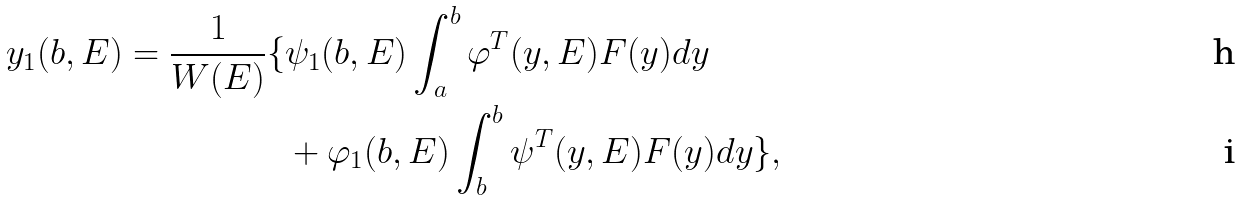<formula> <loc_0><loc_0><loc_500><loc_500>y _ { 1 } ( b , E ) = \frac { 1 } { W ( E ) } \{ & \psi _ { 1 } ( b , E ) \int ^ { b } _ { a } \varphi ^ { T } ( y , E ) F ( y ) d y \\ & + \varphi _ { 1 } ( b , E ) \int ^ { b } _ { b } \psi ^ { T } ( y , E ) F ( y ) d y \} ,</formula> 